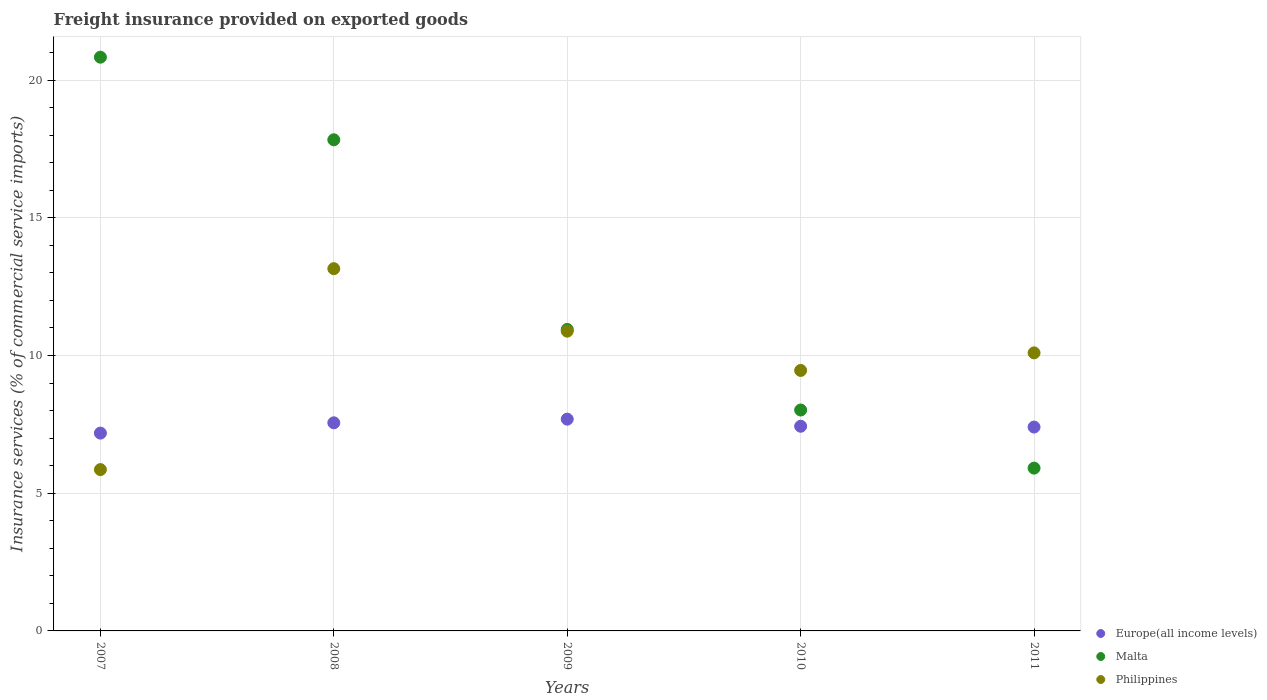What is the freight insurance provided on exported goods in Malta in 2009?
Give a very brief answer. 10.95. Across all years, what is the maximum freight insurance provided on exported goods in Philippines?
Offer a very short reply. 13.15. Across all years, what is the minimum freight insurance provided on exported goods in Malta?
Your answer should be very brief. 5.91. What is the total freight insurance provided on exported goods in Malta in the graph?
Provide a succinct answer. 63.54. What is the difference between the freight insurance provided on exported goods in Philippines in 2008 and that in 2009?
Provide a succinct answer. 2.27. What is the difference between the freight insurance provided on exported goods in Malta in 2011 and the freight insurance provided on exported goods in Europe(all income levels) in 2007?
Ensure brevity in your answer.  -1.27. What is the average freight insurance provided on exported goods in Philippines per year?
Offer a terse response. 9.89. In the year 2007, what is the difference between the freight insurance provided on exported goods in Malta and freight insurance provided on exported goods in Europe(all income levels)?
Your answer should be compact. 13.65. In how many years, is the freight insurance provided on exported goods in Europe(all income levels) greater than 15 %?
Make the answer very short. 0. What is the ratio of the freight insurance provided on exported goods in Europe(all income levels) in 2010 to that in 2011?
Provide a succinct answer. 1. Is the freight insurance provided on exported goods in Malta in 2009 less than that in 2010?
Your answer should be compact. No. Is the difference between the freight insurance provided on exported goods in Malta in 2009 and 2011 greater than the difference between the freight insurance provided on exported goods in Europe(all income levels) in 2009 and 2011?
Provide a short and direct response. Yes. What is the difference between the highest and the second highest freight insurance provided on exported goods in Europe(all income levels)?
Offer a terse response. 0.13. What is the difference between the highest and the lowest freight insurance provided on exported goods in Philippines?
Give a very brief answer. 7.3. Is it the case that in every year, the sum of the freight insurance provided on exported goods in Europe(all income levels) and freight insurance provided on exported goods in Philippines  is greater than the freight insurance provided on exported goods in Malta?
Provide a succinct answer. No. Does the freight insurance provided on exported goods in Malta monotonically increase over the years?
Provide a succinct answer. No. Is the freight insurance provided on exported goods in Philippines strictly less than the freight insurance provided on exported goods in Malta over the years?
Make the answer very short. No. How many years are there in the graph?
Offer a terse response. 5. Where does the legend appear in the graph?
Your answer should be very brief. Bottom right. How many legend labels are there?
Provide a short and direct response. 3. How are the legend labels stacked?
Make the answer very short. Vertical. What is the title of the graph?
Provide a succinct answer. Freight insurance provided on exported goods. Does "Puerto Rico" appear as one of the legend labels in the graph?
Your response must be concise. No. What is the label or title of the Y-axis?
Your response must be concise. Insurance services (% of commercial service imports). What is the Insurance services (% of commercial service imports) of Europe(all income levels) in 2007?
Give a very brief answer. 7.18. What is the Insurance services (% of commercial service imports) of Malta in 2007?
Offer a very short reply. 20.83. What is the Insurance services (% of commercial service imports) in Philippines in 2007?
Provide a succinct answer. 5.86. What is the Insurance services (% of commercial service imports) of Europe(all income levels) in 2008?
Your response must be concise. 7.56. What is the Insurance services (% of commercial service imports) of Malta in 2008?
Ensure brevity in your answer.  17.83. What is the Insurance services (% of commercial service imports) of Philippines in 2008?
Make the answer very short. 13.15. What is the Insurance services (% of commercial service imports) of Europe(all income levels) in 2009?
Give a very brief answer. 7.69. What is the Insurance services (% of commercial service imports) of Malta in 2009?
Your answer should be very brief. 10.95. What is the Insurance services (% of commercial service imports) of Philippines in 2009?
Your answer should be compact. 10.88. What is the Insurance services (% of commercial service imports) of Europe(all income levels) in 2010?
Keep it short and to the point. 7.43. What is the Insurance services (% of commercial service imports) of Malta in 2010?
Provide a short and direct response. 8.02. What is the Insurance services (% of commercial service imports) in Philippines in 2010?
Ensure brevity in your answer.  9.46. What is the Insurance services (% of commercial service imports) in Europe(all income levels) in 2011?
Your answer should be very brief. 7.4. What is the Insurance services (% of commercial service imports) of Malta in 2011?
Your answer should be compact. 5.91. What is the Insurance services (% of commercial service imports) in Philippines in 2011?
Your answer should be compact. 10.1. Across all years, what is the maximum Insurance services (% of commercial service imports) of Europe(all income levels)?
Offer a terse response. 7.69. Across all years, what is the maximum Insurance services (% of commercial service imports) of Malta?
Ensure brevity in your answer.  20.83. Across all years, what is the maximum Insurance services (% of commercial service imports) in Philippines?
Provide a short and direct response. 13.15. Across all years, what is the minimum Insurance services (% of commercial service imports) of Europe(all income levels)?
Give a very brief answer. 7.18. Across all years, what is the minimum Insurance services (% of commercial service imports) of Malta?
Provide a short and direct response. 5.91. Across all years, what is the minimum Insurance services (% of commercial service imports) of Philippines?
Your answer should be very brief. 5.86. What is the total Insurance services (% of commercial service imports) of Europe(all income levels) in the graph?
Make the answer very short. 37.26. What is the total Insurance services (% of commercial service imports) of Malta in the graph?
Offer a terse response. 63.54. What is the total Insurance services (% of commercial service imports) of Philippines in the graph?
Offer a terse response. 49.45. What is the difference between the Insurance services (% of commercial service imports) of Europe(all income levels) in 2007 and that in 2008?
Keep it short and to the point. -0.37. What is the difference between the Insurance services (% of commercial service imports) of Malta in 2007 and that in 2008?
Make the answer very short. 3. What is the difference between the Insurance services (% of commercial service imports) in Philippines in 2007 and that in 2008?
Provide a short and direct response. -7.3. What is the difference between the Insurance services (% of commercial service imports) in Europe(all income levels) in 2007 and that in 2009?
Make the answer very short. -0.51. What is the difference between the Insurance services (% of commercial service imports) of Malta in 2007 and that in 2009?
Provide a short and direct response. 9.89. What is the difference between the Insurance services (% of commercial service imports) in Philippines in 2007 and that in 2009?
Provide a short and direct response. -5.03. What is the difference between the Insurance services (% of commercial service imports) in Europe(all income levels) in 2007 and that in 2010?
Your answer should be very brief. -0.25. What is the difference between the Insurance services (% of commercial service imports) of Malta in 2007 and that in 2010?
Your response must be concise. 12.81. What is the difference between the Insurance services (% of commercial service imports) in Philippines in 2007 and that in 2010?
Ensure brevity in your answer.  -3.6. What is the difference between the Insurance services (% of commercial service imports) in Europe(all income levels) in 2007 and that in 2011?
Offer a very short reply. -0.22. What is the difference between the Insurance services (% of commercial service imports) in Malta in 2007 and that in 2011?
Your response must be concise. 14.92. What is the difference between the Insurance services (% of commercial service imports) in Philippines in 2007 and that in 2011?
Keep it short and to the point. -4.24. What is the difference between the Insurance services (% of commercial service imports) of Europe(all income levels) in 2008 and that in 2009?
Ensure brevity in your answer.  -0.13. What is the difference between the Insurance services (% of commercial service imports) of Malta in 2008 and that in 2009?
Your answer should be very brief. 6.89. What is the difference between the Insurance services (% of commercial service imports) in Philippines in 2008 and that in 2009?
Provide a succinct answer. 2.27. What is the difference between the Insurance services (% of commercial service imports) of Europe(all income levels) in 2008 and that in 2010?
Make the answer very short. 0.12. What is the difference between the Insurance services (% of commercial service imports) of Malta in 2008 and that in 2010?
Provide a succinct answer. 9.81. What is the difference between the Insurance services (% of commercial service imports) in Philippines in 2008 and that in 2010?
Your response must be concise. 3.7. What is the difference between the Insurance services (% of commercial service imports) in Europe(all income levels) in 2008 and that in 2011?
Your answer should be very brief. 0.15. What is the difference between the Insurance services (% of commercial service imports) of Malta in 2008 and that in 2011?
Ensure brevity in your answer.  11.92. What is the difference between the Insurance services (% of commercial service imports) in Philippines in 2008 and that in 2011?
Offer a terse response. 3.06. What is the difference between the Insurance services (% of commercial service imports) in Europe(all income levels) in 2009 and that in 2010?
Give a very brief answer. 0.26. What is the difference between the Insurance services (% of commercial service imports) of Malta in 2009 and that in 2010?
Give a very brief answer. 2.93. What is the difference between the Insurance services (% of commercial service imports) of Philippines in 2009 and that in 2010?
Keep it short and to the point. 1.43. What is the difference between the Insurance services (% of commercial service imports) in Europe(all income levels) in 2009 and that in 2011?
Your answer should be compact. 0.29. What is the difference between the Insurance services (% of commercial service imports) in Malta in 2009 and that in 2011?
Provide a short and direct response. 5.04. What is the difference between the Insurance services (% of commercial service imports) of Philippines in 2009 and that in 2011?
Provide a succinct answer. 0.79. What is the difference between the Insurance services (% of commercial service imports) of Europe(all income levels) in 2010 and that in 2011?
Offer a very short reply. 0.03. What is the difference between the Insurance services (% of commercial service imports) in Malta in 2010 and that in 2011?
Give a very brief answer. 2.11. What is the difference between the Insurance services (% of commercial service imports) of Philippines in 2010 and that in 2011?
Keep it short and to the point. -0.64. What is the difference between the Insurance services (% of commercial service imports) of Europe(all income levels) in 2007 and the Insurance services (% of commercial service imports) of Malta in 2008?
Keep it short and to the point. -10.65. What is the difference between the Insurance services (% of commercial service imports) in Europe(all income levels) in 2007 and the Insurance services (% of commercial service imports) in Philippines in 2008?
Your response must be concise. -5.97. What is the difference between the Insurance services (% of commercial service imports) in Malta in 2007 and the Insurance services (% of commercial service imports) in Philippines in 2008?
Give a very brief answer. 7.68. What is the difference between the Insurance services (% of commercial service imports) of Europe(all income levels) in 2007 and the Insurance services (% of commercial service imports) of Malta in 2009?
Offer a terse response. -3.76. What is the difference between the Insurance services (% of commercial service imports) of Europe(all income levels) in 2007 and the Insurance services (% of commercial service imports) of Philippines in 2009?
Give a very brief answer. -3.7. What is the difference between the Insurance services (% of commercial service imports) in Malta in 2007 and the Insurance services (% of commercial service imports) in Philippines in 2009?
Your response must be concise. 9.95. What is the difference between the Insurance services (% of commercial service imports) of Europe(all income levels) in 2007 and the Insurance services (% of commercial service imports) of Malta in 2010?
Provide a short and direct response. -0.84. What is the difference between the Insurance services (% of commercial service imports) of Europe(all income levels) in 2007 and the Insurance services (% of commercial service imports) of Philippines in 2010?
Your answer should be compact. -2.28. What is the difference between the Insurance services (% of commercial service imports) in Malta in 2007 and the Insurance services (% of commercial service imports) in Philippines in 2010?
Your answer should be compact. 11.37. What is the difference between the Insurance services (% of commercial service imports) in Europe(all income levels) in 2007 and the Insurance services (% of commercial service imports) in Malta in 2011?
Your answer should be compact. 1.27. What is the difference between the Insurance services (% of commercial service imports) in Europe(all income levels) in 2007 and the Insurance services (% of commercial service imports) in Philippines in 2011?
Ensure brevity in your answer.  -2.91. What is the difference between the Insurance services (% of commercial service imports) in Malta in 2007 and the Insurance services (% of commercial service imports) in Philippines in 2011?
Offer a terse response. 10.74. What is the difference between the Insurance services (% of commercial service imports) of Europe(all income levels) in 2008 and the Insurance services (% of commercial service imports) of Malta in 2009?
Give a very brief answer. -3.39. What is the difference between the Insurance services (% of commercial service imports) in Europe(all income levels) in 2008 and the Insurance services (% of commercial service imports) in Philippines in 2009?
Provide a succinct answer. -3.33. What is the difference between the Insurance services (% of commercial service imports) in Malta in 2008 and the Insurance services (% of commercial service imports) in Philippines in 2009?
Your answer should be very brief. 6.95. What is the difference between the Insurance services (% of commercial service imports) of Europe(all income levels) in 2008 and the Insurance services (% of commercial service imports) of Malta in 2010?
Offer a very short reply. -0.46. What is the difference between the Insurance services (% of commercial service imports) in Europe(all income levels) in 2008 and the Insurance services (% of commercial service imports) in Philippines in 2010?
Keep it short and to the point. -1.9. What is the difference between the Insurance services (% of commercial service imports) in Malta in 2008 and the Insurance services (% of commercial service imports) in Philippines in 2010?
Your answer should be very brief. 8.38. What is the difference between the Insurance services (% of commercial service imports) in Europe(all income levels) in 2008 and the Insurance services (% of commercial service imports) in Malta in 2011?
Provide a succinct answer. 1.65. What is the difference between the Insurance services (% of commercial service imports) of Europe(all income levels) in 2008 and the Insurance services (% of commercial service imports) of Philippines in 2011?
Your response must be concise. -2.54. What is the difference between the Insurance services (% of commercial service imports) of Malta in 2008 and the Insurance services (% of commercial service imports) of Philippines in 2011?
Keep it short and to the point. 7.74. What is the difference between the Insurance services (% of commercial service imports) in Europe(all income levels) in 2009 and the Insurance services (% of commercial service imports) in Malta in 2010?
Your response must be concise. -0.33. What is the difference between the Insurance services (% of commercial service imports) in Europe(all income levels) in 2009 and the Insurance services (% of commercial service imports) in Philippines in 2010?
Give a very brief answer. -1.77. What is the difference between the Insurance services (% of commercial service imports) in Malta in 2009 and the Insurance services (% of commercial service imports) in Philippines in 2010?
Give a very brief answer. 1.49. What is the difference between the Insurance services (% of commercial service imports) of Europe(all income levels) in 2009 and the Insurance services (% of commercial service imports) of Malta in 2011?
Provide a succinct answer. 1.78. What is the difference between the Insurance services (% of commercial service imports) in Europe(all income levels) in 2009 and the Insurance services (% of commercial service imports) in Philippines in 2011?
Your response must be concise. -2.41. What is the difference between the Insurance services (% of commercial service imports) of Malta in 2009 and the Insurance services (% of commercial service imports) of Philippines in 2011?
Provide a succinct answer. 0.85. What is the difference between the Insurance services (% of commercial service imports) of Europe(all income levels) in 2010 and the Insurance services (% of commercial service imports) of Malta in 2011?
Offer a very short reply. 1.52. What is the difference between the Insurance services (% of commercial service imports) of Europe(all income levels) in 2010 and the Insurance services (% of commercial service imports) of Philippines in 2011?
Provide a short and direct response. -2.66. What is the difference between the Insurance services (% of commercial service imports) in Malta in 2010 and the Insurance services (% of commercial service imports) in Philippines in 2011?
Your answer should be very brief. -2.07. What is the average Insurance services (% of commercial service imports) of Europe(all income levels) per year?
Keep it short and to the point. 7.45. What is the average Insurance services (% of commercial service imports) in Malta per year?
Offer a very short reply. 12.71. What is the average Insurance services (% of commercial service imports) in Philippines per year?
Your response must be concise. 9.89. In the year 2007, what is the difference between the Insurance services (% of commercial service imports) in Europe(all income levels) and Insurance services (% of commercial service imports) in Malta?
Provide a short and direct response. -13.65. In the year 2007, what is the difference between the Insurance services (% of commercial service imports) in Europe(all income levels) and Insurance services (% of commercial service imports) in Philippines?
Give a very brief answer. 1.32. In the year 2007, what is the difference between the Insurance services (% of commercial service imports) in Malta and Insurance services (% of commercial service imports) in Philippines?
Your answer should be compact. 14.97. In the year 2008, what is the difference between the Insurance services (% of commercial service imports) of Europe(all income levels) and Insurance services (% of commercial service imports) of Malta?
Ensure brevity in your answer.  -10.28. In the year 2008, what is the difference between the Insurance services (% of commercial service imports) of Europe(all income levels) and Insurance services (% of commercial service imports) of Philippines?
Ensure brevity in your answer.  -5.6. In the year 2008, what is the difference between the Insurance services (% of commercial service imports) of Malta and Insurance services (% of commercial service imports) of Philippines?
Your answer should be very brief. 4.68. In the year 2009, what is the difference between the Insurance services (% of commercial service imports) in Europe(all income levels) and Insurance services (% of commercial service imports) in Malta?
Your response must be concise. -3.26. In the year 2009, what is the difference between the Insurance services (% of commercial service imports) of Europe(all income levels) and Insurance services (% of commercial service imports) of Philippines?
Give a very brief answer. -3.19. In the year 2009, what is the difference between the Insurance services (% of commercial service imports) in Malta and Insurance services (% of commercial service imports) in Philippines?
Offer a terse response. 0.06. In the year 2010, what is the difference between the Insurance services (% of commercial service imports) in Europe(all income levels) and Insurance services (% of commercial service imports) in Malta?
Provide a short and direct response. -0.59. In the year 2010, what is the difference between the Insurance services (% of commercial service imports) of Europe(all income levels) and Insurance services (% of commercial service imports) of Philippines?
Make the answer very short. -2.03. In the year 2010, what is the difference between the Insurance services (% of commercial service imports) in Malta and Insurance services (% of commercial service imports) in Philippines?
Ensure brevity in your answer.  -1.44. In the year 2011, what is the difference between the Insurance services (% of commercial service imports) of Europe(all income levels) and Insurance services (% of commercial service imports) of Malta?
Provide a short and direct response. 1.49. In the year 2011, what is the difference between the Insurance services (% of commercial service imports) of Europe(all income levels) and Insurance services (% of commercial service imports) of Philippines?
Offer a terse response. -2.69. In the year 2011, what is the difference between the Insurance services (% of commercial service imports) of Malta and Insurance services (% of commercial service imports) of Philippines?
Offer a very short reply. -4.18. What is the ratio of the Insurance services (% of commercial service imports) in Europe(all income levels) in 2007 to that in 2008?
Give a very brief answer. 0.95. What is the ratio of the Insurance services (% of commercial service imports) in Malta in 2007 to that in 2008?
Your answer should be very brief. 1.17. What is the ratio of the Insurance services (% of commercial service imports) in Philippines in 2007 to that in 2008?
Give a very brief answer. 0.45. What is the ratio of the Insurance services (% of commercial service imports) of Europe(all income levels) in 2007 to that in 2009?
Make the answer very short. 0.93. What is the ratio of the Insurance services (% of commercial service imports) of Malta in 2007 to that in 2009?
Provide a short and direct response. 1.9. What is the ratio of the Insurance services (% of commercial service imports) in Philippines in 2007 to that in 2009?
Provide a short and direct response. 0.54. What is the ratio of the Insurance services (% of commercial service imports) in Europe(all income levels) in 2007 to that in 2010?
Provide a succinct answer. 0.97. What is the ratio of the Insurance services (% of commercial service imports) in Malta in 2007 to that in 2010?
Your response must be concise. 2.6. What is the ratio of the Insurance services (% of commercial service imports) in Philippines in 2007 to that in 2010?
Provide a succinct answer. 0.62. What is the ratio of the Insurance services (% of commercial service imports) of Europe(all income levels) in 2007 to that in 2011?
Ensure brevity in your answer.  0.97. What is the ratio of the Insurance services (% of commercial service imports) in Malta in 2007 to that in 2011?
Your answer should be compact. 3.52. What is the ratio of the Insurance services (% of commercial service imports) in Philippines in 2007 to that in 2011?
Give a very brief answer. 0.58. What is the ratio of the Insurance services (% of commercial service imports) in Europe(all income levels) in 2008 to that in 2009?
Your answer should be very brief. 0.98. What is the ratio of the Insurance services (% of commercial service imports) in Malta in 2008 to that in 2009?
Provide a short and direct response. 1.63. What is the ratio of the Insurance services (% of commercial service imports) of Philippines in 2008 to that in 2009?
Offer a very short reply. 1.21. What is the ratio of the Insurance services (% of commercial service imports) of Europe(all income levels) in 2008 to that in 2010?
Give a very brief answer. 1.02. What is the ratio of the Insurance services (% of commercial service imports) in Malta in 2008 to that in 2010?
Provide a succinct answer. 2.22. What is the ratio of the Insurance services (% of commercial service imports) in Philippines in 2008 to that in 2010?
Your answer should be very brief. 1.39. What is the ratio of the Insurance services (% of commercial service imports) in Europe(all income levels) in 2008 to that in 2011?
Make the answer very short. 1.02. What is the ratio of the Insurance services (% of commercial service imports) in Malta in 2008 to that in 2011?
Give a very brief answer. 3.02. What is the ratio of the Insurance services (% of commercial service imports) of Philippines in 2008 to that in 2011?
Provide a short and direct response. 1.3. What is the ratio of the Insurance services (% of commercial service imports) of Europe(all income levels) in 2009 to that in 2010?
Give a very brief answer. 1.03. What is the ratio of the Insurance services (% of commercial service imports) in Malta in 2009 to that in 2010?
Your answer should be very brief. 1.36. What is the ratio of the Insurance services (% of commercial service imports) in Philippines in 2009 to that in 2010?
Ensure brevity in your answer.  1.15. What is the ratio of the Insurance services (% of commercial service imports) of Europe(all income levels) in 2009 to that in 2011?
Make the answer very short. 1.04. What is the ratio of the Insurance services (% of commercial service imports) of Malta in 2009 to that in 2011?
Your response must be concise. 1.85. What is the ratio of the Insurance services (% of commercial service imports) in Philippines in 2009 to that in 2011?
Ensure brevity in your answer.  1.08. What is the ratio of the Insurance services (% of commercial service imports) of Europe(all income levels) in 2010 to that in 2011?
Provide a short and direct response. 1. What is the ratio of the Insurance services (% of commercial service imports) in Malta in 2010 to that in 2011?
Provide a succinct answer. 1.36. What is the ratio of the Insurance services (% of commercial service imports) in Philippines in 2010 to that in 2011?
Make the answer very short. 0.94. What is the difference between the highest and the second highest Insurance services (% of commercial service imports) in Europe(all income levels)?
Your response must be concise. 0.13. What is the difference between the highest and the second highest Insurance services (% of commercial service imports) of Malta?
Give a very brief answer. 3. What is the difference between the highest and the second highest Insurance services (% of commercial service imports) of Philippines?
Your response must be concise. 2.27. What is the difference between the highest and the lowest Insurance services (% of commercial service imports) of Europe(all income levels)?
Give a very brief answer. 0.51. What is the difference between the highest and the lowest Insurance services (% of commercial service imports) of Malta?
Your response must be concise. 14.92. What is the difference between the highest and the lowest Insurance services (% of commercial service imports) in Philippines?
Offer a terse response. 7.3. 